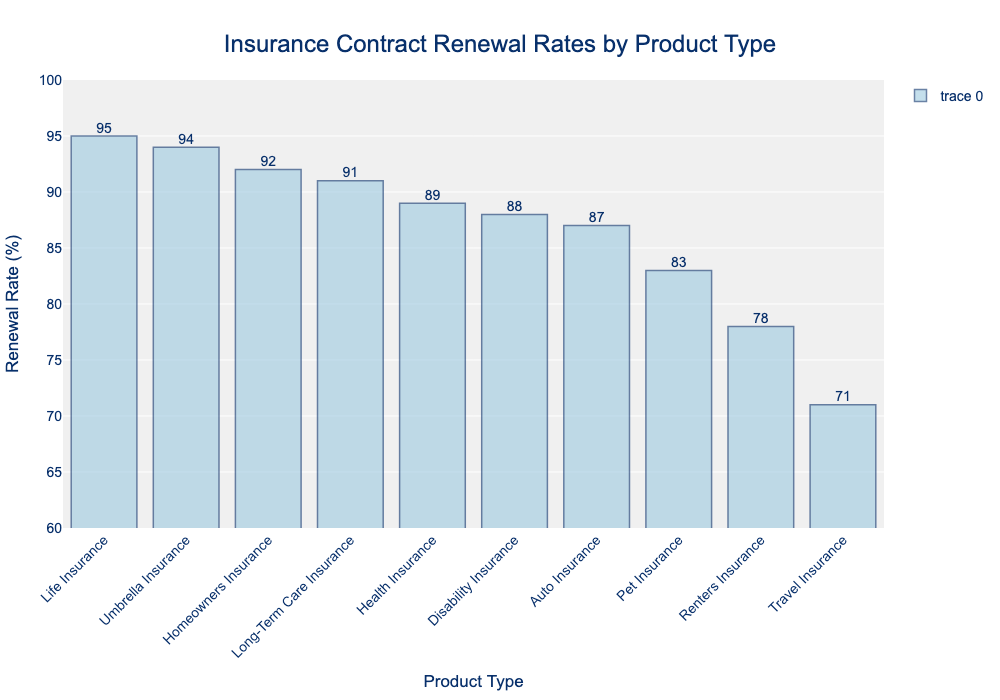Which product type has the highest renewal rate? The highest bar in the chart represents the product type with the highest renewal rate, which is Life Insurance at 95%.
Answer: Life Insurance How many product types have a renewal rate above 90%? By looking at the chart, we can see that Life Insurance (95%), Umbrella Insurance (94%), Homeowners Insurance (92%), and Long-Term Care Insurance (91%) have renewal rates above 90%. There are 4 such product types in total.
Answer: 4 What is the difference in renewal rate between the highest and the lowest product types? The highest renewal rate is for Life Insurance at 95%, and the lowest is Travel Insurance at 71%. The difference is 95% - 71% = 24%.
Answer: 24% Which product type has a renewal rate just below Umbrella Insurance? By examining the bars in descending order, we see that Long-Term Care Insurance with a renewal rate of 91% is just below Umbrella Insurance at 94%.
Answer: Long-Term Care Insurance What is the average renewal rate of Auto Insurance, Homeowners Insurance, and Disability Insurance? Auto Insurance is 87%, Homeowners Insurance is 92%, and Disability Insurance is 88%. The average is (87 + 92 + 88) / 3 = 89%.
Answer: 89% Which product types have renewal rates between 80% and 90%? Looking at the chart, Health Insurance (89%), Disability Insurance (88%), Auto Insurance (87%), Pet Insurance (83%), and Renters Insurance (78%) have renewal rates in this range. There are 5 such product types.
Answer: 5 How much higher is the renewal rate for Homeowners Insurance compared to Renters Insurance? Homeowners Insurance has a renewal rate of 92% while Renters Insurance is at 78%. The difference is 92% - 78% = 14%.
Answer: 14% Which product types have the closest renewal rates? Pet Insurance and Auto Insurance have renewal rates of 83% and 87%, respectively, making them the closest with a difference of only 4%.
Answer: Pet Insurance and Auto Insurance What percentage of product types have a renewal rate of at least 85%? Out of 10 product types, 8 have renewal rates of at least 85% (all except Renters Insurance and Travel Insurance). This is (8 / 10) * 100% = 80%.
Answer: 80% Which product type has a renewal rate closest to 90%? The product type with a renewal rate closest to 90% is Health Insurance, which has a renewal rate of 89%.
Answer: Health Insurance 